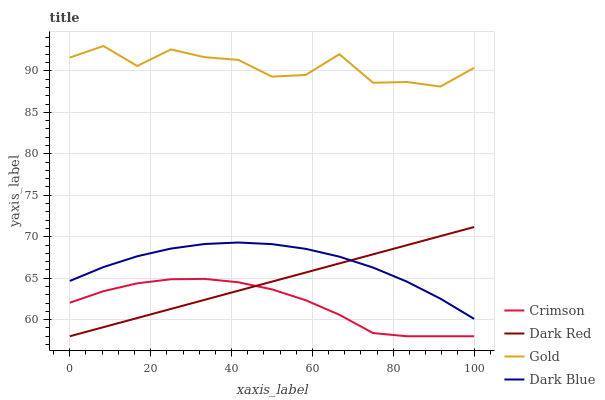Does Dark Red have the minimum area under the curve?
Answer yes or no. No. Does Dark Red have the maximum area under the curve?
Answer yes or no. No. Is Gold the smoothest?
Answer yes or no. No. Is Dark Red the roughest?
Answer yes or no. No. Does Gold have the lowest value?
Answer yes or no. No. Does Dark Red have the highest value?
Answer yes or no. No. Is Crimson less than Dark Blue?
Answer yes or no. Yes. Is Gold greater than Dark Red?
Answer yes or no. Yes. Does Crimson intersect Dark Blue?
Answer yes or no. No. 